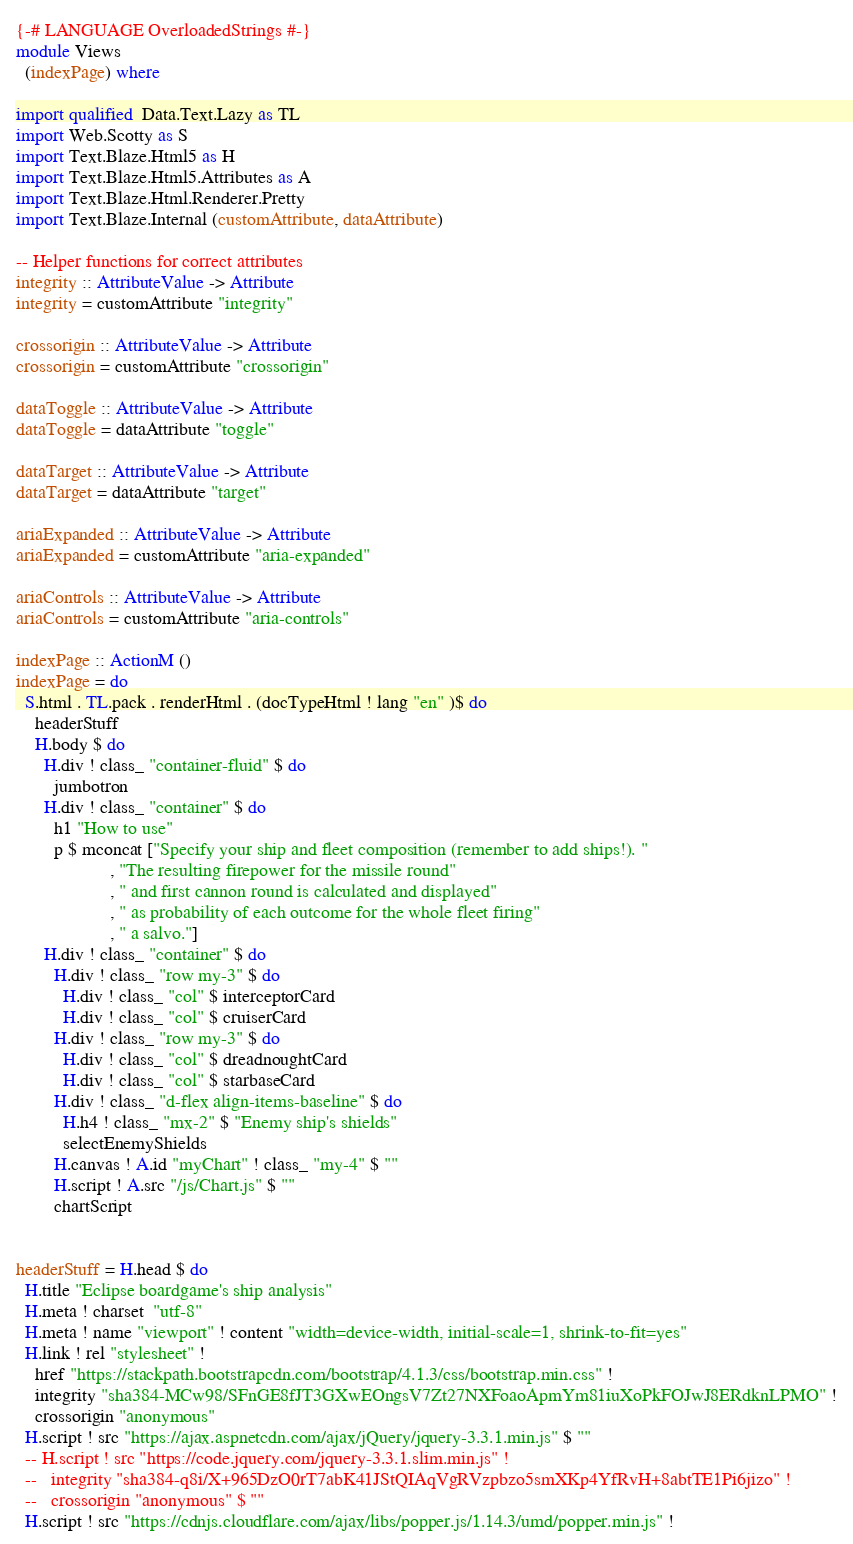<code> <loc_0><loc_0><loc_500><loc_500><_Haskell_>{-# LANGUAGE OverloadedStrings #-}
module Views
  (indexPage) where

import qualified  Data.Text.Lazy as TL
import Web.Scotty as S
import Text.Blaze.Html5 as H
import Text.Blaze.Html5.Attributes as A
import Text.Blaze.Html.Renderer.Pretty
import Text.Blaze.Internal (customAttribute, dataAttribute)

-- Helper functions for correct attributes
integrity :: AttributeValue -> Attribute
integrity = customAttribute "integrity"

crossorigin :: AttributeValue -> Attribute
crossorigin = customAttribute "crossorigin"

dataToggle :: AttributeValue -> Attribute
dataToggle = dataAttribute "toggle"

dataTarget :: AttributeValue -> Attribute
dataTarget = dataAttribute "target"

ariaExpanded :: AttributeValue -> Attribute
ariaExpanded = customAttribute "aria-expanded"

ariaControls :: AttributeValue -> Attribute
ariaControls = customAttribute "aria-controls"

indexPage :: ActionM ()
indexPage = do
  S.html . TL.pack . renderHtml . (docTypeHtml ! lang "en" )$ do
    headerStuff   
    H.body $ do
      H.div ! class_ "container-fluid" $ do
        jumbotron
      H.div ! class_ "container" $ do
        h1 "How to use"
        p $ mconcat ["Specify your ship and fleet composition (remember to add ships!). "
                    , "The resulting firepower for the missile round"
                    , " and first cannon round is calculated and displayed"
                    , " as probability of each outcome for the whole fleet firing"
                    , " a salvo."]
      H.div ! class_ "container" $ do
        H.div ! class_ "row my-3" $ do
          H.div ! class_ "col" $ interceptorCard
          H.div ! class_ "col" $ cruiserCard
        H.div ! class_ "row my-3" $ do
          H.div ! class_ "col" $ dreadnoughtCard
          H.div ! class_ "col" $ starbaseCard
        H.div ! class_ "d-flex align-items-baseline" $ do
          H.h4 ! class_ "mx-2" $ "Enemy ship's shields"
          selectEnemyShields 
        H.canvas ! A.id "myChart" ! class_ "my-4" $ ""
        H.script ! A.src "/js/Chart.js" $ ""
        chartScript


headerStuff = H.head $ do
  H.title "Eclipse boardgame's ship analysis"
  H.meta ! charset  "utf-8"
  H.meta ! name "viewport" ! content "width=device-width, initial-scale=1, shrink-to-fit=yes" 
  H.link ! rel "stylesheet" !
    href "https://stackpath.bootstrapcdn.com/bootstrap/4.1.3/css/bootstrap.min.css" !
    integrity "sha384-MCw98/SFnGE8fJT3GXwEOngsV7Zt27NXFoaoApmYm81iuXoPkFOJwJ8ERdknLPMO" !
    crossorigin "anonymous"
  H.script ! src "https://ajax.aspnetcdn.com/ajax/jQuery/jquery-3.3.1.min.js" $ ""
  -- H.script ! src "https://code.jquery.com/jquery-3.3.1.slim.min.js" !
  --   integrity "sha384-q8i/X+965DzO0rT7abK41JStQIAqVgRVzpbzo5smXKp4YfRvH+8abtTE1Pi6jizo" !
  --   crossorigin "anonymous" $ ""
  H.script ! src "https://cdnjs.cloudflare.com/ajax/libs/popper.js/1.14.3/umd/popper.min.js" !</code> 